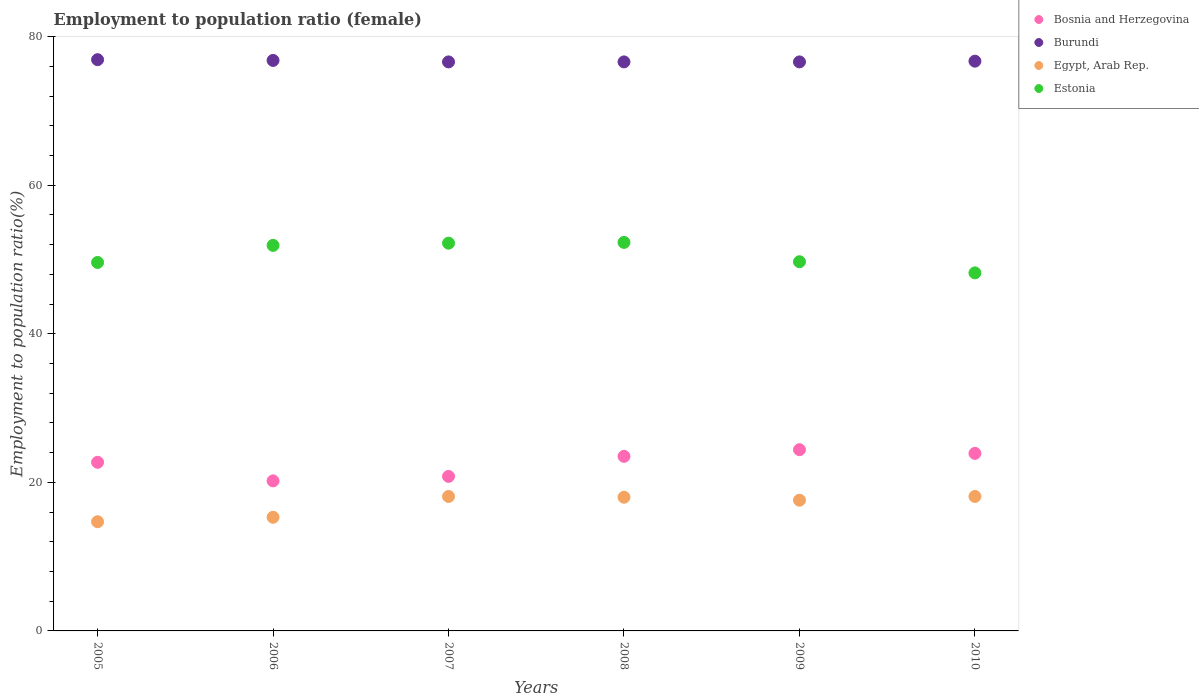What is the employment to population ratio in Burundi in 2007?
Offer a very short reply. 76.6. Across all years, what is the maximum employment to population ratio in Burundi?
Provide a succinct answer. 76.9. Across all years, what is the minimum employment to population ratio in Bosnia and Herzegovina?
Make the answer very short. 20.2. In which year was the employment to population ratio in Egypt, Arab Rep. minimum?
Provide a short and direct response. 2005. What is the total employment to population ratio in Egypt, Arab Rep. in the graph?
Provide a short and direct response. 101.8. What is the difference between the employment to population ratio in Estonia in 2007 and the employment to population ratio in Burundi in 2009?
Ensure brevity in your answer.  -24.4. What is the average employment to population ratio in Estonia per year?
Keep it short and to the point. 50.65. In the year 2010, what is the difference between the employment to population ratio in Bosnia and Herzegovina and employment to population ratio in Burundi?
Your response must be concise. -52.8. What is the ratio of the employment to population ratio in Burundi in 2006 to that in 2009?
Provide a succinct answer. 1. What is the difference between the highest and the second highest employment to population ratio in Estonia?
Your answer should be compact. 0.1. What is the difference between the highest and the lowest employment to population ratio in Bosnia and Herzegovina?
Keep it short and to the point. 4.2. Is it the case that in every year, the sum of the employment to population ratio in Bosnia and Herzegovina and employment to population ratio in Egypt, Arab Rep.  is greater than the sum of employment to population ratio in Burundi and employment to population ratio in Estonia?
Keep it short and to the point. No. Is it the case that in every year, the sum of the employment to population ratio in Estonia and employment to population ratio in Egypt, Arab Rep.  is greater than the employment to population ratio in Burundi?
Your answer should be very brief. No. Is the employment to population ratio in Bosnia and Herzegovina strictly greater than the employment to population ratio in Burundi over the years?
Offer a very short reply. No. Is the employment to population ratio in Egypt, Arab Rep. strictly less than the employment to population ratio in Bosnia and Herzegovina over the years?
Provide a short and direct response. Yes. How many dotlines are there?
Provide a succinct answer. 4. How many years are there in the graph?
Offer a terse response. 6. Where does the legend appear in the graph?
Your response must be concise. Top right. What is the title of the graph?
Provide a short and direct response. Employment to population ratio (female). What is the label or title of the Y-axis?
Make the answer very short. Employment to population ratio(%). What is the Employment to population ratio(%) of Bosnia and Herzegovina in 2005?
Make the answer very short. 22.7. What is the Employment to population ratio(%) in Burundi in 2005?
Keep it short and to the point. 76.9. What is the Employment to population ratio(%) of Egypt, Arab Rep. in 2005?
Offer a terse response. 14.7. What is the Employment to population ratio(%) in Estonia in 2005?
Provide a short and direct response. 49.6. What is the Employment to population ratio(%) of Bosnia and Herzegovina in 2006?
Offer a terse response. 20.2. What is the Employment to population ratio(%) in Burundi in 2006?
Offer a very short reply. 76.8. What is the Employment to population ratio(%) in Egypt, Arab Rep. in 2006?
Your answer should be very brief. 15.3. What is the Employment to population ratio(%) of Estonia in 2006?
Provide a succinct answer. 51.9. What is the Employment to population ratio(%) in Bosnia and Herzegovina in 2007?
Keep it short and to the point. 20.8. What is the Employment to population ratio(%) of Burundi in 2007?
Provide a succinct answer. 76.6. What is the Employment to population ratio(%) in Egypt, Arab Rep. in 2007?
Provide a short and direct response. 18.1. What is the Employment to population ratio(%) in Estonia in 2007?
Keep it short and to the point. 52.2. What is the Employment to population ratio(%) in Burundi in 2008?
Provide a succinct answer. 76.6. What is the Employment to population ratio(%) of Egypt, Arab Rep. in 2008?
Offer a terse response. 18. What is the Employment to population ratio(%) in Estonia in 2008?
Ensure brevity in your answer.  52.3. What is the Employment to population ratio(%) in Bosnia and Herzegovina in 2009?
Give a very brief answer. 24.4. What is the Employment to population ratio(%) in Burundi in 2009?
Provide a short and direct response. 76.6. What is the Employment to population ratio(%) of Egypt, Arab Rep. in 2009?
Provide a short and direct response. 17.6. What is the Employment to population ratio(%) of Estonia in 2009?
Keep it short and to the point. 49.7. What is the Employment to population ratio(%) of Bosnia and Herzegovina in 2010?
Give a very brief answer. 23.9. What is the Employment to population ratio(%) in Burundi in 2010?
Give a very brief answer. 76.7. What is the Employment to population ratio(%) in Egypt, Arab Rep. in 2010?
Give a very brief answer. 18.1. What is the Employment to population ratio(%) in Estonia in 2010?
Make the answer very short. 48.2. Across all years, what is the maximum Employment to population ratio(%) in Bosnia and Herzegovina?
Your answer should be compact. 24.4. Across all years, what is the maximum Employment to population ratio(%) of Burundi?
Your answer should be compact. 76.9. Across all years, what is the maximum Employment to population ratio(%) in Egypt, Arab Rep.?
Ensure brevity in your answer.  18.1. Across all years, what is the maximum Employment to population ratio(%) of Estonia?
Offer a very short reply. 52.3. Across all years, what is the minimum Employment to population ratio(%) in Bosnia and Herzegovina?
Offer a very short reply. 20.2. Across all years, what is the minimum Employment to population ratio(%) in Burundi?
Your answer should be compact. 76.6. Across all years, what is the minimum Employment to population ratio(%) of Egypt, Arab Rep.?
Keep it short and to the point. 14.7. Across all years, what is the minimum Employment to population ratio(%) of Estonia?
Ensure brevity in your answer.  48.2. What is the total Employment to population ratio(%) in Bosnia and Herzegovina in the graph?
Your answer should be very brief. 135.5. What is the total Employment to population ratio(%) in Burundi in the graph?
Offer a very short reply. 460.2. What is the total Employment to population ratio(%) of Egypt, Arab Rep. in the graph?
Provide a short and direct response. 101.8. What is the total Employment to population ratio(%) of Estonia in the graph?
Provide a short and direct response. 303.9. What is the difference between the Employment to population ratio(%) of Bosnia and Herzegovina in 2005 and that in 2006?
Ensure brevity in your answer.  2.5. What is the difference between the Employment to population ratio(%) in Burundi in 2005 and that in 2007?
Give a very brief answer. 0.3. What is the difference between the Employment to population ratio(%) in Estonia in 2005 and that in 2007?
Your answer should be compact. -2.6. What is the difference between the Employment to population ratio(%) in Bosnia and Herzegovina in 2005 and that in 2008?
Provide a succinct answer. -0.8. What is the difference between the Employment to population ratio(%) of Burundi in 2005 and that in 2008?
Your response must be concise. 0.3. What is the difference between the Employment to population ratio(%) of Egypt, Arab Rep. in 2005 and that in 2008?
Offer a very short reply. -3.3. What is the difference between the Employment to population ratio(%) of Estonia in 2005 and that in 2008?
Provide a short and direct response. -2.7. What is the difference between the Employment to population ratio(%) in Bosnia and Herzegovina in 2005 and that in 2009?
Offer a very short reply. -1.7. What is the difference between the Employment to population ratio(%) in Burundi in 2005 and that in 2009?
Offer a terse response. 0.3. What is the difference between the Employment to population ratio(%) of Estonia in 2005 and that in 2009?
Give a very brief answer. -0.1. What is the difference between the Employment to population ratio(%) in Egypt, Arab Rep. in 2005 and that in 2010?
Provide a short and direct response. -3.4. What is the difference between the Employment to population ratio(%) of Estonia in 2005 and that in 2010?
Your response must be concise. 1.4. What is the difference between the Employment to population ratio(%) of Burundi in 2006 and that in 2007?
Offer a terse response. 0.2. What is the difference between the Employment to population ratio(%) in Bosnia and Herzegovina in 2006 and that in 2008?
Give a very brief answer. -3.3. What is the difference between the Employment to population ratio(%) of Egypt, Arab Rep. in 2006 and that in 2008?
Keep it short and to the point. -2.7. What is the difference between the Employment to population ratio(%) of Bosnia and Herzegovina in 2006 and that in 2009?
Your answer should be very brief. -4.2. What is the difference between the Employment to population ratio(%) of Egypt, Arab Rep. in 2006 and that in 2009?
Your response must be concise. -2.3. What is the difference between the Employment to population ratio(%) of Estonia in 2006 and that in 2009?
Keep it short and to the point. 2.2. What is the difference between the Employment to population ratio(%) in Burundi in 2006 and that in 2010?
Give a very brief answer. 0.1. What is the difference between the Employment to population ratio(%) in Egypt, Arab Rep. in 2006 and that in 2010?
Your answer should be compact. -2.8. What is the difference between the Employment to population ratio(%) of Estonia in 2006 and that in 2010?
Give a very brief answer. 3.7. What is the difference between the Employment to population ratio(%) of Bosnia and Herzegovina in 2007 and that in 2008?
Give a very brief answer. -2.7. What is the difference between the Employment to population ratio(%) of Egypt, Arab Rep. in 2007 and that in 2008?
Make the answer very short. 0.1. What is the difference between the Employment to population ratio(%) of Estonia in 2007 and that in 2008?
Keep it short and to the point. -0.1. What is the difference between the Employment to population ratio(%) in Bosnia and Herzegovina in 2007 and that in 2009?
Provide a short and direct response. -3.6. What is the difference between the Employment to population ratio(%) of Estonia in 2007 and that in 2009?
Keep it short and to the point. 2.5. What is the difference between the Employment to population ratio(%) in Bosnia and Herzegovina in 2007 and that in 2010?
Keep it short and to the point. -3.1. What is the difference between the Employment to population ratio(%) of Egypt, Arab Rep. in 2007 and that in 2010?
Give a very brief answer. 0. What is the difference between the Employment to population ratio(%) in Bosnia and Herzegovina in 2008 and that in 2009?
Give a very brief answer. -0.9. What is the difference between the Employment to population ratio(%) of Burundi in 2008 and that in 2009?
Provide a short and direct response. 0. What is the difference between the Employment to population ratio(%) in Egypt, Arab Rep. in 2008 and that in 2009?
Ensure brevity in your answer.  0.4. What is the difference between the Employment to population ratio(%) of Estonia in 2008 and that in 2009?
Make the answer very short. 2.6. What is the difference between the Employment to population ratio(%) in Estonia in 2008 and that in 2010?
Offer a terse response. 4.1. What is the difference between the Employment to population ratio(%) in Burundi in 2009 and that in 2010?
Your answer should be compact. -0.1. What is the difference between the Employment to population ratio(%) of Egypt, Arab Rep. in 2009 and that in 2010?
Offer a terse response. -0.5. What is the difference between the Employment to population ratio(%) of Bosnia and Herzegovina in 2005 and the Employment to population ratio(%) of Burundi in 2006?
Provide a succinct answer. -54.1. What is the difference between the Employment to population ratio(%) of Bosnia and Herzegovina in 2005 and the Employment to population ratio(%) of Egypt, Arab Rep. in 2006?
Provide a succinct answer. 7.4. What is the difference between the Employment to population ratio(%) of Bosnia and Herzegovina in 2005 and the Employment to population ratio(%) of Estonia in 2006?
Ensure brevity in your answer.  -29.2. What is the difference between the Employment to population ratio(%) in Burundi in 2005 and the Employment to population ratio(%) in Egypt, Arab Rep. in 2006?
Provide a short and direct response. 61.6. What is the difference between the Employment to population ratio(%) of Egypt, Arab Rep. in 2005 and the Employment to population ratio(%) of Estonia in 2006?
Keep it short and to the point. -37.2. What is the difference between the Employment to population ratio(%) of Bosnia and Herzegovina in 2005 and the Employment to population ratio(%) of Burundi in 2007?
Offer a terse response. -53.9. What is the difference between the Employment to population ratio(%) of Bosnia and Herzegovina in 2005 and the Employment to population ratio(%) of Egypt, Arab Rep. in 2007?
Your response must be concise. 4.6. What is the difference between the Employment to population ratio(%) of Bosnia and Herzegovina in 2005 and the Employment to population ratio(%) of Estonia in 2007?
Your response must be concise. -29.5. What is the difference between the Employment to population ratio(%) in Burundi in 2005 and the Employment to population ratio(%) in Egypt, Arab Rep. in 2007?
Give a very brief answer. 58.8. What is the difference between the Employment to population ratio(%) of Burundi in 2005 and the Employment to population ratio(%) of Estonia in 2007?
Provide a short and direct response. 24.7. What is the difference between the Employment to population ratio(%) of Egypt, Arab Rep. in 2005 and the Employment to population ratio(%) of Estonia in 2007?
Your answer should be very brief. -37.5. What is the difference between the Employment to population ratio(%) of Bosnia and Herzegovina in 2005 and the Employment to population ratio(%) of Burundi in 2008?
Provide a short and direct response. -53.9. What is the difference between the Employment to population ratio(%) of Bosnia and Herzegovina in 2005 and the Employment to population ratio(%) of Egypt, Arab Rep. in 2008?
Ensure brevity in your answer.  4.7. What is the difference between the Employment to population ratio(%) in Bosnia and Herzegovina in 2005 and the Employment to population ratio(%) in Estonia in 2008?
Your answer should be very brief. -29.6. What is the difference between the Employment to population ratio(%) of Burundi in 2005 and the Employment to population ratio(%) of Egypt, Arab Rep. in 2008?
Keep it short and to the point. 58.9. What is the difference between the Employment to population ratio(%) in Burundi in 2005 and the Employment to population ratio(%) in Estonia in 2008?
Your answer should be compact. 24.6. What is the difference between the Employment to population ratio(%) of Egypt, Arab Rep. in 2005 and the Employment to population ratio(%) of Estonia in 2008?
Your answer should be compact. -37.6. What is the difference between the Employment to population ratio(%) in Bosnia and Herzegovina in 2005 and the Employment to population ratio(%) in Burundi in 2009?
Your answer should be compact. -53.9. What is the difference between the Employment to population ratio(%) in Burundi in 2005 and the Employment to population ratio(%) in Egypt, Arab Rep. in 2009?
Your response must be concise. 59.3. What is the difference between the Employment to population ratio(%) of Burundi in 2005 and the Employment to population ratio(%) of Estonia in 2009?
Offer a very short reply. 27.2. What is the difference between the Employment to population ratio(%) in Egypt, Arab Rep. in 2005 and the Employment to population ratio(%) in Estonia in 2009?
Keep it short and to the point. -35. What is the difference between the Employment to population ratio(%) of Bosnia and Herzegovina in 2005 and the Employment to population ratio(%) of Burundi in 2010?
Make the answer very short. -54. What is the difference between the Employment to population ratio(%) of Bosnia and Herzegovina in 2005 and the Employment to population ratio(%) of Egypt, Arab Rep. in 2010?
Ensure brevity in your answer.  4.6. What is the difference between the Employment to population ratio(%) in Bosnia and Herzegovina in 2005 and the Employment to population ratio(%) in Estonia in 2010?
Keep it short and to the point. -25.5. What is the difference between the Employment to population ratio(%) of Burundi in 2005 and the Employment to population ratio(%) of Egypt, Arab Rep. in 2010?
Your answer should be very brief. 58.8. What is the difference between the Employment to population ratio(%) of Burundi in 2005 and the Employment to population ratio(%) of Estonia in 2010?
Keep it short and to the point. 28.7. What is the difference between the Employment to population ratio(%) in Egypt, Arab Rep. in 2005 and the Employment to population ratio(%) in Estonia in 2010?
Make the answer very short. -33.5. What is the difference between the Employment to population ratio(%) of Bosnia and Herzegovina in 2006 and the Employment to population ratio(%) of Burundi in 2007?
Your answer should be very brief. -56.4. What is the difference between the Employment to population ratio(%) of Bosnia and Herzegovina in 2006 and the Employment to population ratio(%) of Egypt, Arab Rep. in 2007?
Provide a short and direct response. 2.1. What is the difference between the Employment to population ratio(%) of Bosnia and Herzegovina in 2006 and the Employment to population ratio(%) of Estonia in 2007?
Provide a succinct answer. -32. What is the difference between the Employment to population ratio(%) in Burundi in 2006 and the Employment to population ratio(%) in Egypt, Arab Rep. in 2007?
Your response must be concise. 58.7. What is the difference between the Employment to population ratio(%) of Burundi in 2006 and the Employment to population ratio(%) of Estonia in 2007?
Give a very brief answer. 24.6. What is the difference between the Employment to population ratio(%) of Egypt, Arab Rep. in 2006 and the Employment to population ratio(%) of Estonia in 2007?
Offer a very short reply. -36.9. What is the difference between the Employment to population ratio(%) in Bosnia and Herzegovina in 2006 and the Employment to population ratio(%) in Burundi in 2008?
Keep it short and to the point. -56.4. What is the difference between the Employment to population ratio(%) of Bosnia and Herzegovina in 2006 and the Employment to population ratio(%) of Egypt, Arab Rep. in 2008?
Offer a terse response. 2.2. What is the difference between the Employment to population ratio(%) in Bosnia and Herzegovina in 2006 and the Employment to population ratio(%) in Estonia in 2008?
Keep it short and to the point. -32.1. What is the difference between the Employment to population ratio(%) in Burundi in 2006 and the Employment to population ratio(%) in Egypt, Arab Rep. in 2008?
Offer a terse response. 58.8. What is the difference between the Employment to population ratio(%) of Egypt, Arab Rep. in 2006 and the Employment to population ratio(%) of Estonia in 2008?
Your response must be concise. -37. What is the difference between the Employment to population ratio(%) in Bosnia and Herzegovina in 2006 and the Employment to population ratio(%) in Burundi in 2009?
Offer a very short reply. -56.4. What is the difference between the Employment to population ratio(%) in Bosnia and Herzegovina in 2006 and the Employment to population ratio(%) in Egypt, Arab Rep. in 2009?
Offer a very short reply. 2.6. What is the difference between the Employment to population ratio(%) of Bosnia and Herzegovina in 2006 and the Employment to population ratio(%) of Estonia in 2009?
Your answer should be very brief. -29.5. What is the difference between the Employment to population ratio(%) of Burundi in 2006 and the Employment to population ratio(%) of Egypt, Arab Rep. in 2009?
Ensure brevity in your answer.  59.2. What is the difference between the Employment to population ratio(%) in Burundi in 2006 and the Employment to population ratio(%) in Estonia in 2009?
Keep it short and to the point. 27.1. What is the difference between the Employment to population ratio(%) of Egypt, Arab Rep. in 2006 and the Employment to population ratio(%) of Estonia in 2009?
Make the answer very short. -34.4. What is the difference between the Employment to population ratio(%) of Bosnia and Herzegovina in 2006 and the Employment to population ratio(%) of Burundi in 2010?
Keep it short and to the point. -56.5. What is the difference between the Employment to population ratio(%) in Bosnia and Herzegovina in 2006 and the Employment to population ratio(%) in Egypt, Arab Rep. in 2010?
Your answer should be compact. 2.1. What is the difference between the Employment to population ratio(%) of Bosnia and Herzegovina in 2006 and the Employment to population ratio(%) of Estonia in 2010?
Provide a succinct answer. -28. What is the difference between the Employment to population ratio(%) of Burundi in 2006 and the Employment to population ratio(%) of Egypt, Arab Rep. in 2010?
Ensure brevity in your answer.  58.7. What is the difference between the Employment to population ratio(%) of Burundi in 2006 and the Employment to population ratio(%) of Estonia in 2010?
Provide a succinct answer. 28.6. What is the difference between the Employment to population ratio(%) of Egypt, Arab Rep. in 2006 and the Employment to population ratio(%) of Estonia in 2010?
Offer a very short reply. -32.9. What is the difference between the Employment to population ratio(%) of Bosnia and Herzegovina in 2007 and the Employment to population ratio(%) of Burundi in 2008?
Offer a terse response. -55.8. What is the difference between the Employment to population ratio(%) in Bosnia and Herzegovina in 2007 and the Employment to population ratio(%) in Egypt, Arab Rep. in 2008?
Provide a short and direct response. 2.8. What is the difference between the Employment to population ratio(%) of Bosnia and Herzegovina in 2007 and the Employment to population ratio(%) of Estonia in 2008?
Ensure brevity in your answer.  -31.5. What is the difference between the Employment to population ratio(%) in Burundi in 2007 and the Employment to population ratio(%) in Egypt, Arab Rep. in 2008?
Provide a succinct answer. 58.6. What is the difference between the Employment to population ratio(%) in Burundi in 2007 and the Employment to population ratio(%) in Estonia in 2008?
Your answer should be compact. 24.3. What is the difference between the Employment to population ratio(%) in Egypt, Arab Rep. in 2007 and the Employment to population ratio(%) in Estonia in 2008?
Offer a terse response. -34.2. What is the difference between the Employment to population ratio(%) in Bosnia and Herzegovina in 2007 and the Employment to population ratio(%) in Burundi in 2009?
Your answer should be compact. -55.8. What is the difference between the Employment to population ratio(%) of Bosnia and Herzegovina in 2007 and the Employment to population ratio(%) of Estonia in 2009?
Ensure brevity in your answer.  -28.9. What is the difference between the Employment to population ratio(%) in Burundi in 2007 and the Employment to population ratio(%) in Egypt, Arab Rep. in 2009?
Provide a short and direct response. 59. What is the difference between the Employment to population ratio(%) of Burundi in 2007 and the Employment to population ratio(%) of Estonia in 2009?
Your answer should be compact. 26.9. What is the difference between the Employment to population ratio(%) of Egypt, Arab Rep. in 2007 and the Employment to population ratio(%) of Estonia in 2009?
Offer a very short reply. -31.6. What is the difference between the Employment to population ratio(%) in Bosnia and Herzegovina in 2007 and the Employment to population ratio(%) in Burundi in 2010?
Provide a short and direct response. -55.9. What is the difference between the Employment to population ratio(%) of Bosnia and Herzegovina in 2007 and the Employment to population ratio(%) of Egypt, Arab Rep. in 2010?
Give a very brief answer. 2.7. What is the difference between the Employment to population ratio(%) of Bosnia and Herzegovina in 2007 and the Employment to population ratio(%) of Estonia in 2010?
Your response must be concise. -27.4. What is the difference between the Employment to population ratio(%) of Burundi in 2007 and the Employment to population ratio(%) of Egypt, Arab Rep. in 2010?
Offer a terse response. 58.5. What is the difference between the Employment to population ratio(%) in Burundi in 2007 and the Employment to population ratio(%) in Estonia in 2010?
Make the answer very short. 28.4. What is the difference between the Employment to population ratio(%) of Egypt, Arab Rep. in 2007 and the Employment to population ratio(%) of Estonia in 2010?
Provide a short and direct response. -30.1. What is the difference between the Employment to population ratio(%) in Bosnia and Herzegovina in 2008 and the Employment to population ratio(%) in Burundi in 2009?
Provide a short and direct response. -53.1. What is the difference between the Employment to population ratio(%) of Bosnia and Herzegovina in 2008 and the Employment to population ratio(%) of Egypt, Arab Rep. in 2009?
Your response must be concise. 5.9. What is the difference between the Employment to population ratio(%) in Bosnia and Herzegovina in 2008 and the Employment to population ratio(%) in Estonia in 2009?
Offer a terse response. -26.2. What is the difference between the Employment to population ratio(%) in Burundi in 2008 and the Employment to population ratio(%) in Egypt, Arab Rep. in 2009?
Make the answer very short. 59. What is the difference between the Employment to population ratio(%) in Burundi in 2008 and the Employment to population ratio(%) in Estonia in 2009?
Give a very brief answer. 26.9. What is the difference between the Employment to population ratio(%) of Egypt, Arab Rep. in 2008 and the Employment to population ratio(%) of Estonia in 2009?
Provide a succinct answer. -31.7. What is the difference between the Employment to population ratio(%) in Bosnia and Herzegovina in 2008 and the Employment to population ratio(%) in Burundi in 2010?
Your answer should be very brief. -53.2. What is the difference between the Employment to population ratio(%) in Bosnia and Herzegovina in 2008 and the Employment to population ratio(%) in Egypt, Arab Rep. in 2010?
Keep it short and to the point. 5.4. What is the difference between the Employment to population ratio(%) in Bosnia and Herzegovina in 2008 and the Employment to population ratio(%) in Estonia in 2010?
Your response must be concise. -24.7. What is the difference between the Employment to population ratio(%) in Burundi in 2008 and the Employment to population ratio(%) in Egypt, Arab Rep. in 2010?
Your response must be concise. 58.5. What is the difference between the Employment to population ratio(%) in Burundi in 2008 and the Employment to population ratio(%) in Estonia in 2010?
Provide a succinct answer. 28.4. What is the difference between the Employment to population ratio(%) of Egypt, Arab Rep. in 2008 and the Employment to population ratio(%) of Estonia in 2010?
Your answer should be compact. -30.2. What is the difference between the Employment to population ratio(%) in Bosnia and Herzegovina in 2009 and the Employment to population ratio(%) in Burundi in 2010?
Offer a terse response. -52.3. What is the difference between the Employment to population ratio(%) in Bosnia and Herzegovina in 2009 and the Employment to population ratio(%) in Egypt, Arab Rep. in 2010?
Offer a terse response. 6.3. What is the difference between the Employment to population ratio(%) of Bosnia and Herzegovina in 2009 and the Employment to population ratio(%) of Estonia in 2010?
Your response must be concise. -23.8. What is the difference between the Employment to population ratio(%) in Burundi in 2009 and the Employment to population ratio(%) in Egypt, Arab Rep. in 2010?
Ensure brevity in your answer.  58.5. What is the difference between the Employment to population ratio(%) in Burundi in 2009 and the Employment to population ratio(%) in Estonia in 2010?
Keep it short and to the point. 28.4. What is the difference between the Employment to population ratio(%) of Egypt, Arab Rep. in 2009 and the Employment to population ratio(%) of Estonia in 2010?
Keep it short and to the point. -30.6. What is the average Employment to population ratio(%) in Bosnia and Herzegovina per year?
Provide a short and direct response. 22.58. What is the average Employment to population ratio(%) of Burundi per year?
Offer a terse response. 76.7. What is the average Employment to population ratio(%) of Egypt, Arab Rep. per year?
Provide a short and direct response. 16.97. What is the average Employment to population ratio(%) of Estonia per year?
Give a very brief answer. 50.65. In the year 2005, what is the difference between the Employment to population ratio(%) of Bosnia and Herzegovina and Employment to population ratio(%) of Burundi?
Your answer should be very brief. -54.2. In the year 2005, what is the difference between the Employment to population ratio(%) of Bosnia and Herzegovina and Employment to population ratio(%) of Estonia?
Your answer should be very brief. -26.9. In the year 2005, what is the difference between the Employment to population ratio(%) of Burundi and Employment to population ratio(%) of Egypt, Arab Rep.?
Provide a succinct answer. 62.2. In the year 2005, what is the difference between the Employment to population ratio(%) of Burundi and Employment to population ratio(%) of Estonia?
Ensure brevity in your answer.  27.3. In the year 2005, what is the difference between the Employment to population ratio(%) in Egypt, Arab Rep. and Employment to population ratio(%) in Estonia?
Make the answer very short. -34.9. In the year 2006, what is the difference between the Employment to population ratio(%) of Bosnia and Herzegovina and Employment to population ratio(%) of Burundi?
Provide a short and direct response. -56.6. In the year 2006, what is the difference between the Employment to population ratio(%) in Bosnia and Herzegovina and Employment to population ratio(%) in Estonia?
Your answer should be very brief. -31.7. In the year 2006, what is the difference between the Employment to population ratio(%) of Burundi and Employment to population ratio(%) of Egypt, Arab Rep.?
Offer a very short reply. 61.5. In the year 2006, what is the difference between the Employment to population ratio(%) in Burundi and Employment to population ratio(%) in Estonia?
Ensure brevity in your answer.  24.9. In the year 2006, what is the difference between the Employment to population ratio(%) in Egypt, Arab Rep. and Employment to population ratio(%) in Estonia?
Ensure brevity in your answer.  -36.6. In the year 2007, what is the difference between the Employment to population ratio(%) of Bosnia and Herzegovina and Employment to population ratio(%) of Burundi?
Offer a terse response. -55.8. In the year 2007, what is the difference between the Employment to population ratio(%) in Bosnia and Herzegovina and Employment to population ratio(%) in Egypt, Arab Rep.?
Your answer should be compact. 2.7. In the year 2007, what is the difference between the Employment to population ratio(%) in Bosnia and Herzegovina and Employment to population ratio(%) in Estonia?
Provide a succinct answer. -31.4. In the year 2007, what is the difference between the Employment to population ratio(%) of Burundi and Employment to population ratio(%) of Egypt, Arab Rep.?
Offer a very short reply. 58.5. In the year 2007, what is the difference between the Employment to population ratio(%) of Burundi and Employment to population ratio(%) of Estonia?
Your response must be concise. 24.4. In the year 2007, what is the difference between the Employment to population ratio(%) of Egypt, Arab Rep. and Employment to population ratio(%) of Estonia?
Offer a very short reply. -34.1. In the year 2008, what is the difference between the Employment to population ratio(%) of Bosnia and Herzegovina and Employment to population ratio(%) of Burundi?
Your answer should be very brief. -53.1. In the year 2008, what is the difference between the Employment to population ratio(%) in Bosnia and Herzegovina and Employment to population ratio(%) in Estonia?
Offer a terse response. -28.8. In the year 2008, what is the difference between the Employment to population ratio(%) of Burundi and Employment to population ratio(%) of Egypt, Arab Rep.?
Offer a terse response. 58.6. In the year 2008, what is the difference between the Employment to population ratio(%) of Burundi and Employment to population ratio(%) of Estonia?
Offer a very short reply. 24.3. In the year 2008, what is the difference between the Employment to population ratio(%) in Egypt, Arab Rep. and Employment to population ratio(%) in Estonia?
Provide a short and direct response. -34.3. In the year 2009, what is the difference between the Employment to population ratio(%) in Bosnia and Herzegovina and Employment to population ratio(%) in Burundi?
Make the answer very short. -52.2. In the year 2009, what is the difference between the Employment to population ratio(%) of Bosnia and Herzegovina and Employment to population ratio(%) of Egypt, Arab Rep.?
Offer a very short reply. 6.8. In the year 2009, what is the difference between the Employment to population ratio(%) of Bosnia and Herzegovina and Employment to population ratio(%) of Estonia?
Provide a succinct answer. -25.3. In the year 2009, what is the difference between the Employment to population ratio(%) in Burundi and Employment to population ratio(%) in Estonia?
Offer a very short reply. 26.9. In the year 2009, what is the difference between the Employment to population ratio(%) in Egypt, Arab Rep. and Employment to population ratio(%) in Estonia?
Give a very brief answer. -32.1. In the year 2010, what is the difference between the Employment to population ratio(%) of Bosnia and Herzegovina and Employment to population ratio(%) of Burundi?
Ensure brevity in your answer.  -52.8. In the year 2010, what is the difference between the Employment to population ratio(%) in Bosnia and Herzegovina and Employment to population ratio(%) in Egypt, Arab Rep.?
Provide a short and direct response. 5.8. In the year 2010, what is the difference between the Employment to population ratio(%) in Bosnia and Herzegovina and Employment to population ratio(%) in Estonia?
Provide a short and direct response. -24.3. In the year 2010, what is the difference between the Employment to population ratio(%) in Burundi and Employment to population ratio(%) in Egypt, Arab Rep.?
Your answer should be very brief. 58.6. In the year 2010, what is the difference between the Employment to population ratio(%) in Egypt, Arab Rep. and Employment to population ratio(%) in Estonia?
Give a very brief answer. -30.1. What is the ratio of the Employment to population ratio(%) of Bosnia and Herzegovina in 2005 to that in 2006?
Offer a terse response. 1.12. What is the ratio of the Employment to population ratio(%) of Burundi in 2005 to that in 2006?
Ensure brevity in your answer.  1. What is the ratio of the Employment to population ratio(%) in Egypt, Arab Rep. in 2005 to that in 2006?
Provide a succinct answer. 0.96. What is the ratio of the Employment to population ratio(%) of Estonia in 2005 to that in 2006?
Your answer should be compact. 0.96. What is the ratio of the Employment to population ratio(%) of Bosnia and Herzegovina in 2005 to that in 2007?
Give a very brief answer. 1.09. What is the ratio of the Employment to population ratio(%) of Egypt, Arab Rep. in 2005 to that in 2007?
Give a very brief answer. 0.81. What is the ratio of the Employment to population ratio(%) in Estonia in 2005 to that in 2007?
Provide a succinct answer. 0.95. What is the ratio of the Employment to population ratio(%) of Bosnia and Herzegovina in 2005 to that in 2008?
Ensure brevity in your answer.  0.97. What is the ratio of the Employment to population ratio(%) in Egypt, Arab Rep. in 2005 to that in 2008?
Your response must be concise. 0.82. What is the ratio of the Employment to population ratio(%) in Estonia in 2005 to that in 2008?
Your answer should be compact. 0.95. What is the ratio of the Employment to population ratio(%) in Bosnia and Herzegovina in 2005 to that in 2009?
Provide a succinct answer. 0.93. What is the ratio of the Employment to population ratio(%) in Egypt, Arab Rep. in 2005 to that in 2009?
Ensure brevity in your answer.  0.84. What is the ratio of the Employment to population ratio(%) in Bosnia and Herzegovina in 2005 to that in 2010?
Make the answer very short. 0.95. What is the ratio of the Employment to population ratio(%) of Burundi in 2005 to that in 2010?
Offer a very short reply. 1. What is the ratio of the Employment to population ratio(%) in Egypt, Arab Rep. in 2005 to that in 2010?
Your answer should be compact. 0.81. What is the ratio of the Employment to population ratio(%) of Estonia in 2005 to that in 2010?
Your answer should be compact. 1.03. What is the ratio of the Employment to population ratio(%) in Bosnia and Herzegovina in 2006 to that in 2007?
Your response must be concise. 0.97. What is the ratio of the Employment to population ratio(%) of Egypt, Arab Rep. in 2006 to that in 2007?
Provide a succinct answer. 0.85. What is the ratio of the Employment to population ratio(%) in Bosnia and Herzegovina in 2006 to that in 2008?
Ensure brevity in your answer.  0.86. What is the ratio of the Employment to population ratio(%) in Burundi in 2006 to that in 2008?
Your response must be concise. 1. What is the ratio of the Employment to population ratio(%) of Estonia in 2006 to that in 2008?
Provide a succinct answer. 0.99. What is the ratio of the Employment to population ratio(%) in Bosnia and Herzegovina in 2006 to that in 2009?
Your answer should be compact. 0.83. What is the ratio of the Employment to population ratio(%) of Burundi in 2006 to that in 2009?
Give a very brief answer. 1. What is the ratio of the Employment to population ratio(%) of Egypt, Arab Rep. in 2006 to that in 2009?
Ensure brevity in your answer.  0.87. What is the ratio of the Employment to population ratio(%) in Estonia in 2006 to that in 2009?
Give a very brief answer. 1.04. What is the ratio of the Employment to population ratio(%) of Bosnia and Herzegovina in 2006 to that in 2010?
Your answer should be very brief. 0.85. What is the ratio of the Employment to population ratio(%) in Egypt, Arab Rep. in 2006 to that in 2010?
Provide a short and direct response. 0.85. What is the ratio of the Employment to population ratio(%) in Estonia in 2006 to that in 2010?
Make the answer very short. 1.08. What is the ratio of the Employment to population ratio(%) in Bosnia and Herzegovina in 2007 to that in 2008?
Your response must be concise. 0.89. What is the ratio of the Employment to population ratio(%) in Burundi in 2007 to that in 2008?
Keep it short and to the point. 1. What is the ratio of the Employment to population ratio(%) of Egypt, Arab Rep. in 2007 to that in 2008?
Your answer should be very brief. 1.01. What is the ratio of the Employment to population ratio(%) of Bosnia and Herzegovina in 2007 to that in 2009?
Your response must be concise. 0.85. What is the ratio of the Employment to population ratio(%) in Egypt, Arab Rep. in 2007 to that in 2009?
Your answer should be very brief. 1.03. What is the ratio of the Employment to population ratio(%) of Estonia in 2007 to that in 2009?
Provide a succinct answer. 1.05. What is the ratio of the Employment to population ratio(%) in Bosnia and Herzegovina in 2007 to that in 2010?
Provide a short and direct response. 0.87. What is the ratio of the Employment to population ratio(%) of Estonia in 2007 to that in 2010?
Offer a very short reply. 1.08. What is the ratio of the Employment to population ratio(%) of Bosnia and Herzegovina in 2008 to that in 2009?
Keep it short and to the point. 0.96. What is the ratio of the Employment to population ratio(%) of Egypt, Arab Rep. in 2008 to that in 2009?
Offer a very short reply. 1.02. What is the ratio of the Employment to population ratio(%) of Estonia in 2008 to that in 2009?
Offer a very short reply. 1.05. What is the ratio of the Employment to population ratio(%) of Bosnia and Herzegovina in 2008 to that in 2010?
Keep it short and to the point. 0.98. What is the ratio of the Employment to population ratio(%) of Burundi in 2008 to that in 2010?
Provide a succinct answer. 1. What is the ratio of the Employment to population ratio(%) of Estonia in 2008 to that in 2010?
Your response must be concise. 1.09. What is the ratio of the Employment to population ratio(%) in Bosnia and Herzegovina in 2009 to that in 2010?
Make the answer very short. 1.02. What is the ratio of the Employment to population ratio(%) of Egypt, Arab Rep. in 2009 to that in 2010?
Your answer should be very brief. 0.97. What is the ratio of the Employment to population ratio(%) in Estonia in 2009 to that in 2010?
Your answer should be very brief. 1.03. What is the difference between the highest and the second highest Employment to population ratio(%) of Bosnia and Herzegovina?
Offer a terse response. 0.5. What is the difference between the highest and the second highest Employment to population ratio(%) in Burundi?
Your response must be concise. 0.1. What is the difference between the highest and the second highest Employment to population ratio(%) of Egypt, Arab Rep.?
Give a very brief answer. 0. What is the difference between the highest and the second highest Employment to population ratio(%) of Estonia?
Your response must be concise. 0.1. What is the difference between the highest and the lowest Employment to population ratio(%) of Burundi?
Your answer should be very brief. 0.3. What is the difference between the highest and the lowest Employment to population ratio(%) of Egypt, Arab Rep.?
Offer a terse response. 3.4. What is the difference between the highest and the lowest Employment to population ratio(%) of Estonia?
Offer a very short reply. 4.1. 